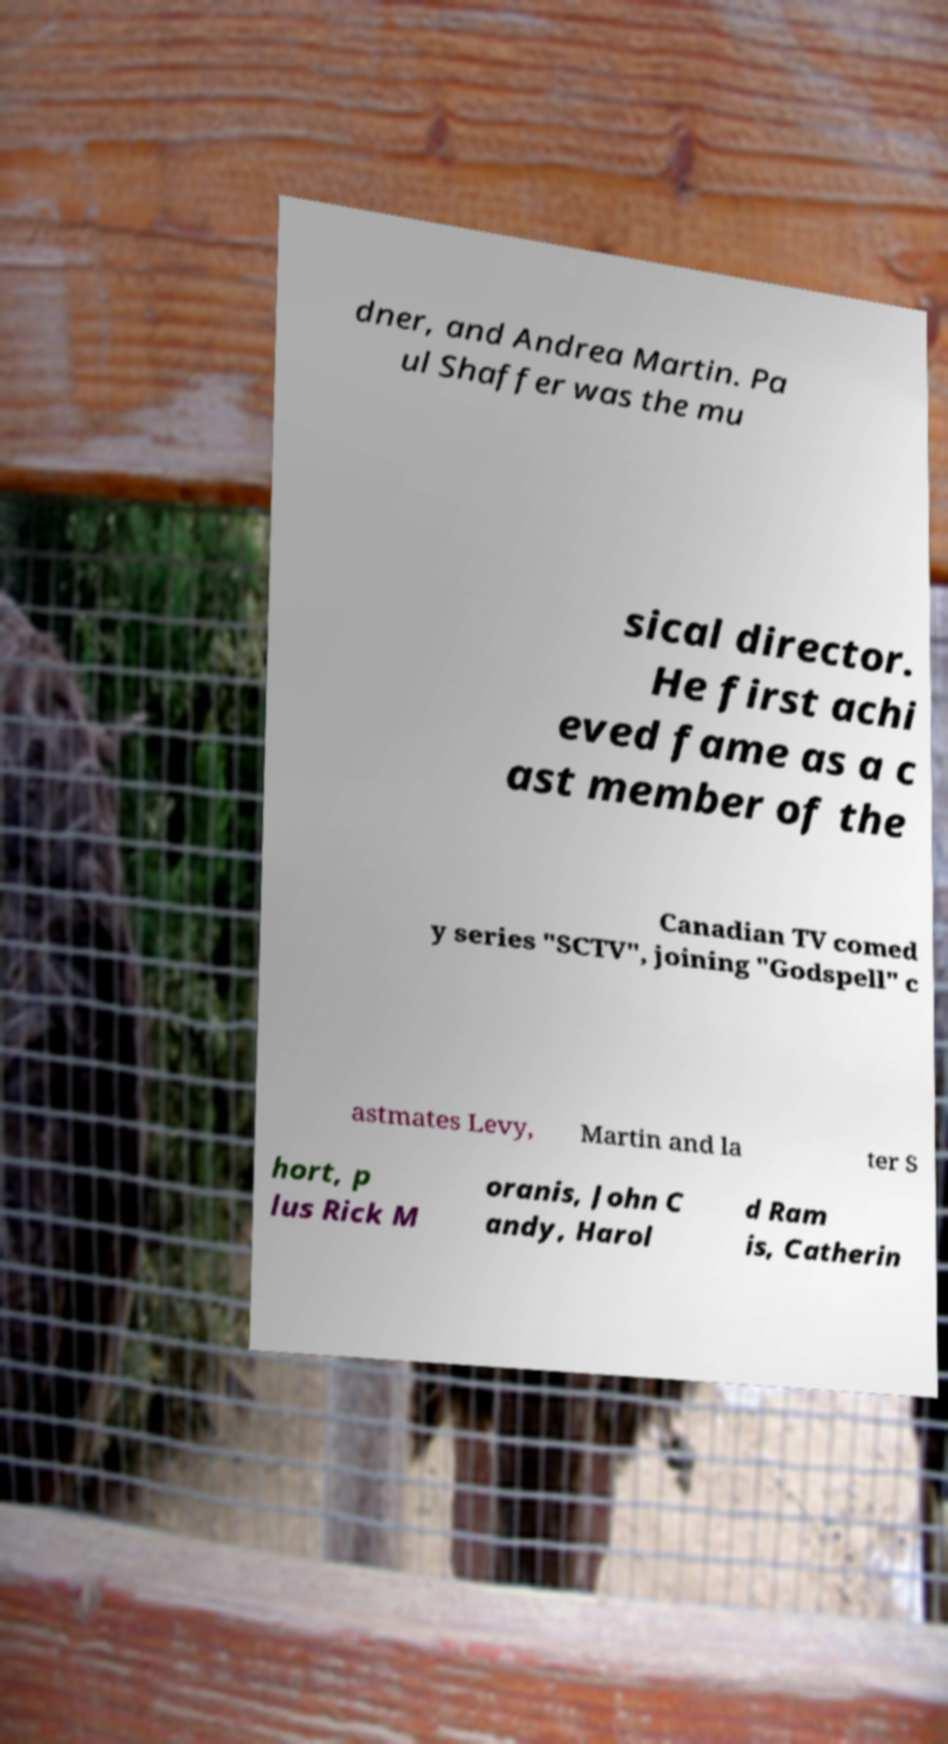Please identify and transcribe the text found in this image. dner, and Andrea Martin. Pa ul Shaffer was the mu sical director. He first achi eved fame as a c ast member of the Canadian TV comed y series "SCTV", joining "Godspell" c astmates Levy, Martin and la ter S hort, p lus Rick M oranis, John C andy, Harol d Ram is, Catherin 